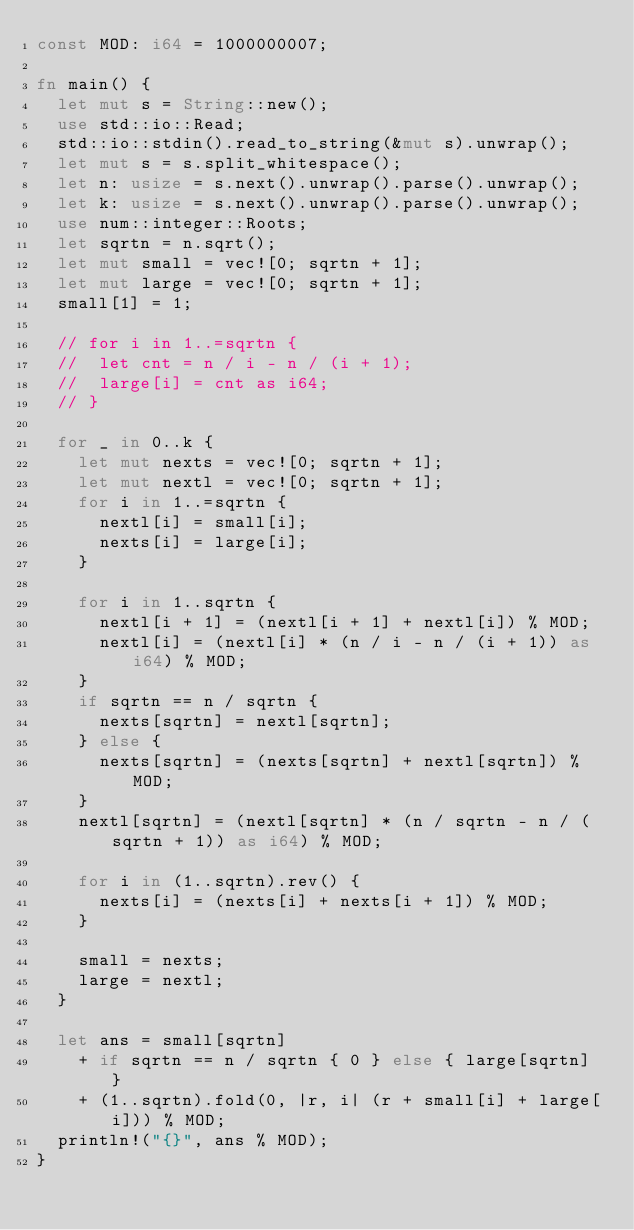<code> <loc_0><loc_0><loc_500><loc_500><_Rust_>const MOD: i64 = 1000000007;

fn main() {
	let mut s = String::new();
	use std::io::Read;
	std::io::stdin().read_to_string(&mut s).unwrap();
	let mut s = s.split_whitespace();
	let n: usize = s.next().unwrap().parse().unwrap();
	let k: usize = s.next().unwrap().parse().unwrap();
	use num::integer::Roots;
	let sqrtn = n.sqrt();
	let mut small = vec![0; sqrtn + 1];
	let mut large = vec![0; sqrtn + 1];
	small[1] = 1;

	// for i in 1..=sqrtn {
	// 	let cnt = n / i - n / (i + 1);
	// 	large[i] = cnt as i64;
	// }

	for _ in 0..k {
		let mut nexts = vec![0; sqrtn + 1];
		let mut nextl = vec![0; sqrtn + 1];
		for i in 1..=sqrtn {
			nextl[i] = small[i];
			nexts[i] = large[i];
		}

		for i in 1..sqrtn {
			nextl[i + 1] = (nextl[i + 1] + nextl[i]) % MOD;
			nextl[i] = (nextl[i] * (n / i - n / (i + 1)) as i64) % MOD;
		}
		if sqrtn == n / sqrtn {
			nexts[sqrtn] = nextl[sqrtn];
		} else {
			nexts[sqrtn] = (nexts[sqrtn] + nextl[sqrtn]) % MOD;
		}
		nextl[sqrtn] = (nextl[sqrtn] * (n / sqrtn - n / (sqrtn + 1)) as i64) % MOD;

		for i in (1..sqrtn).rev() {
			nexts[i] = (nexts[i] + nexts[i + 1]) % MOD;
		}

		small = nexts;
		large = nextl;
	}

	let ans = small[sqrtn]
		+ if sqrtn == n / sqrtn { 0 } else { large[sqrtn] }
		+ (1..sqrtn).fold(0, |r, i| (r + small[i] + large[i])) % MOD;
	println!("{}", ans % MOD);
}
</code> 